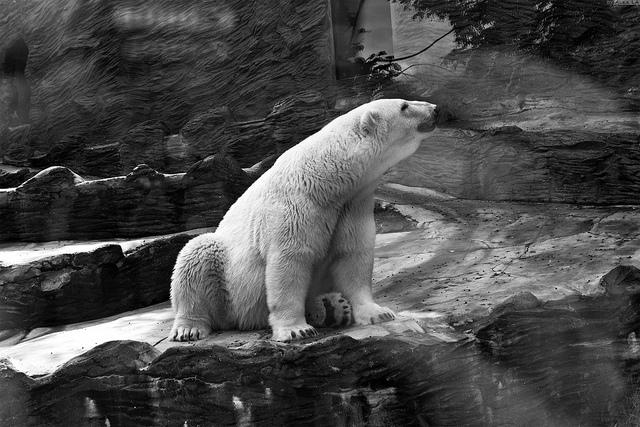Does the bear sitting up look queenly?
Be succinct. Yes. Does the bear look towards the camera?
Give a very brief answer. No. What is the bear smelling?
Answer briefly. Fish. What color is this animal?
Write a very short answer. White. Is this a color photograph?
Short answer required. No. 